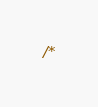<code> <loc_0><loc_0><loc_500><loc_500><_C_>/*</code> 